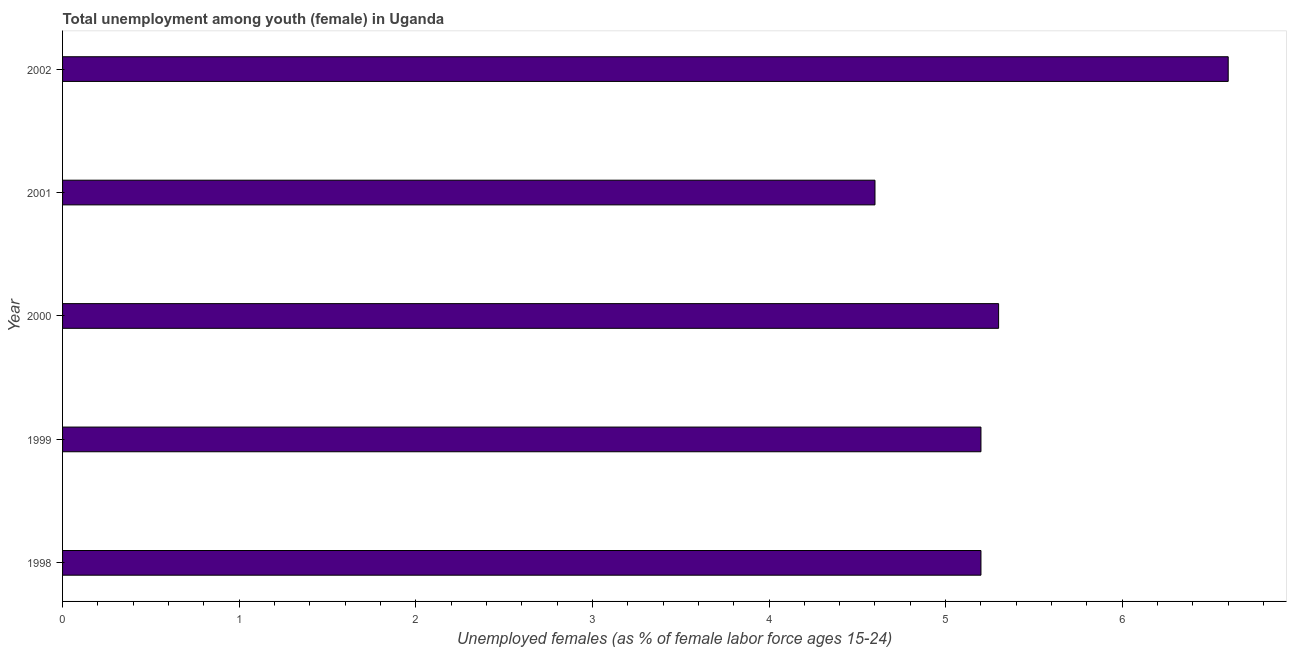Does the graph contain grids?
Provide a short and direct response. No. What is the title of the graph?
Keep it short and to the point. Total unemployment among youth (female) in Uganda. What is the label or title of the X-axis?
Provide a succinct answer. Unemployed females (as % of female labor force ages 15-24). What is the unemployed female youth population in 1999?
Offer a very short reply. 5.2. Across all years, what is the maximum unemployed female youth population?
Your answer should be very brief. 6.6. Across all years, what is the minimum unemployed female youth population?
Provide a short and direct response. 4.6. In which year was the unemployed female youth population maximum?
Make the answer very short. 2002. In which year was the unemployed female youth population minimum?
Give a very brief answer. 2001. What is the sum of the unemployed female youth population?
Offer a very short reply. 26.9. What is the difference between the unemployed female youth population in 1999 and 2000?
Your answer should be very brief. -0.1. What is the average unemployed female youth population per year?
Provide a succinct answer. 5.38. What is the median unemployed female youth population?
Make the answer very short. 5.2. Do a majority of the years between 1999 and 2000 (inclusive) have unemployed female youth population greater than 2 %?
Offer a very short reply. Yes. What is the ratio of the unemployed female youth population in 1999 to that in 2001?
Ensure brevity in your answer.  1.13. Is the unemployed female youth population in 2001 less than that in 2002?
Your response must be concise. Yes. What is the difference between the highest and the second highest unemployed female youth population?
Keep it short and to the point. 1.3. What is the difference between the highest and the lowest unemployed female youth population?
Give a very brief answer. 2. How many years are there in the graph?
Your answer should be compact. 5. What is the difference between two consecutive major ticks on the X-axis?
Ensure brevity in your answer.  1. What is the Unemployed females (as % of female labor force ages 15-24) in 1998?
Your response must be concise. 5.2. What is the Unemployed females (as % of female labor force ages 15-24) in 1999?
Offer a terse response. 5.2. What is the Unemployed females (as % of female labor force ages 15-24) in 2000?
Offer a very short reply. 5.3. What is the Unemployed females (as % of female labor force ages 15-24) in 2001?
Make the answer very short. 4.6. What is the Unemployed females (as % of female labor force ages 15-24) of 2002?
Ensure brevity in your answer.  6.6. What is the difference between the Unemployed females (as % of female labor force ages 15-24) in 1998 and 1999?
Provide a short and direct response. 0. What is the difference between the Unemployed females (as % of female labor force ages 15-24) in 1998 and 2001?
Keep it short and to the point. 0.6. What is the difference between the Unemployed females (as % of female labor force ages 15-24) in 1999 and 2002?
Offer a very short reply. -1.4. What is the difference between the Unemployed females (as % of female labor force ages 15-24) in 2001 and 2002?
Make the answer very short. -2. What is the ratio of the Unemployed females (as % of female labor force ages 15-24) in 1998 to that in 2000?
Your response must be concise. 0.98. What is the ratio of the Unemployed females (as % of female labor force ages 15-24) in 1998 to that in 2001?
Offer a very short reply. 1.13. What is the ratio of the Unemployed females (as % of female labor force ages 15-24) in 1998 to that in 2002?
Make the answer very short. 0.79. What is the ratio of the Unemployed females (as % of female labor force ages 15-24) in 1999 to that in 2000?
Make the answer very short. 0.98. What is the ratio of the Unemployed females (as % of female labor force ages 15-24) in 1999 to that in 2001?
Your answer should be very brief. 1.13. What is the ratio of the Unemployed females (as % of female labor force ages 15-24) in 1999 to that in 2002?
Your answer should be very brief. 0.79. What is the ratio of the Unemployed females (as % of female labor force ages 15-24) in 2000 to that in 2001?
Provide a succinct answer. 1.15. What is the ratio of the Unemployed females (as % of female labor force ages 15-24) in 2000 to that in 2002?
Make the answer very short. 0.8. What is the ratio of the Unemployed females (as % of female labor force ages 15-24) in 2001 to that in 2002?
Give a very brief answer. 0.7. 